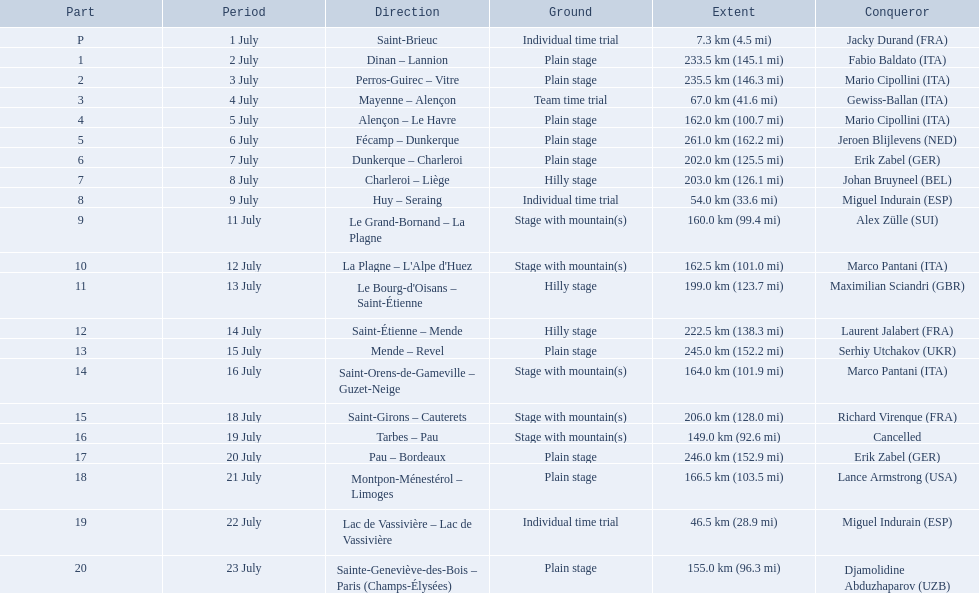What were the lengths of all the stages of the 1995 tour de france? 7.3 km (4.5 mi), 233.5 km (145.1 mi), 235.5 km (146.3 mi), 67.0 km (41.6 mi), 162.0 km (100.7 mi), 261.0 km (162.2 mi), 202.0 km (125.5 mi), 203.0 km (126.1 mi), 54.0 km (33.6 mi), 160.0 km (99.4 mi), 162.5 km (101.0 mi), 199.0 km (123.7 mi), 222.5 km (138.3 mi), 245.0 km (152.2 mi), 164.0 km (101.9 mi), 206.0 km (128.0 mi), 149.0 km (92.6 mi), 246.0 km (152.9 mi), 166.5 km (103.5 mi), 46.5 km (28.9 mi), 155.0 km (96.3 mi). Of those, which one occurred on july 8th? 203.0 km (126.1 mi). 